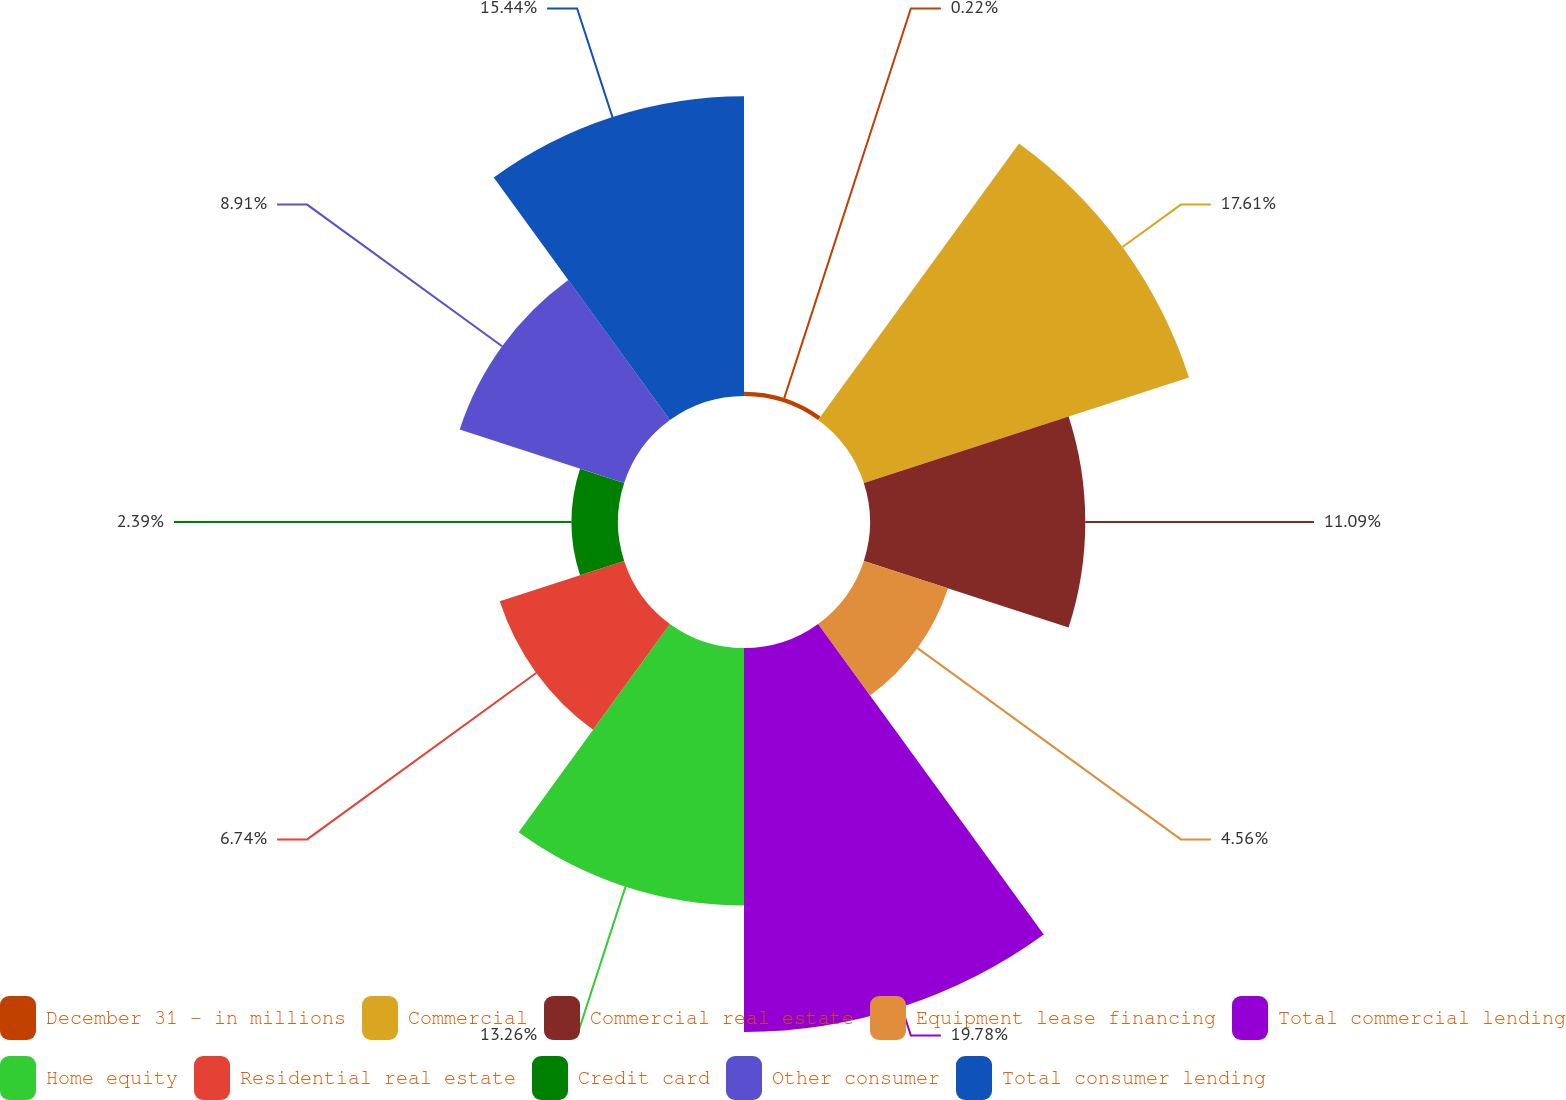Convert chart. <chart><loc_0><loc_0><loc_500><loc_500><pie_chart><fcel>December 31 - in millions<fcel>Commercial<fcel>Commercial real estate<fcel>Equipment lease financing<fcel>Total commercial lending<fcel>Home equity<fcel>Residential real estate<fcel>Credit card<fcel>Other consumer<fcel>Total consumer lending<nl><fcel>0.22%<fcel>17.61%<fcel>11.09%<fcel>4.56%<fcel>19.78%<fcel>13.26%<fcel>6.74%<fcel>2.39%<fcel>8.91%<fcel>15.44%<nl></chart> 